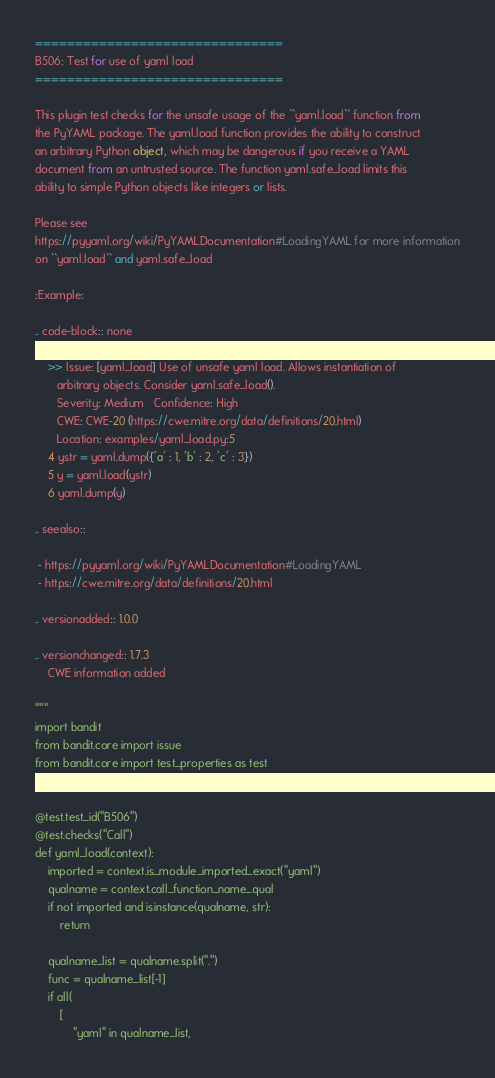<code> <loc_0><loc_0><loc_500><loc_500><_Python_>===============================
B506: Test for use of yaml load
===============================

This plugin test checks for the unsafe usage of the ``yaml.load`` function from
the PyYAML package. The yaml.load function provides the ability to construct
an arbitrary Python object, which may be dangerous if you receive a YAML
document from an untrusted source. The function yaml.safe_load limits this
ability to simple Python objects like integers or lists.

Please see
https://pyyaml.org/wiki/PyYAMLDocumentation#LoadingYAML for more information
on ``yaml.load`` and yaml.safe_load

:Example:

.. code-block:: none

    >> Issue: [yaml_load] Use of unsafe yaml load. Allows instantiation of
       arbitrary objects. Consider yaml.safe_load().
       Severity: Medium   Confidence: High
       CWE: CWE-20 (https://cwe.mitre.org/data/definitions/20.html)
       Location: examples/yaml_load.py:5
    4 ystr = yaml.dump({'a' : 1, 'b' : 2, 'c' : 3})
    5 y = yaml.load(ystr)
    6 yaml.dump(y)

.. seealso::

 - https://pyyaml.org/wiki/PyYAMLDocumentation#LoadingYAML
 - https://cwe.mitre.org/data/definitions/20.html

.. versionadded:: 1.0.0

.. versionchanged:: 1.7.3
    CWE information added

"""
import bandit
from bandit.core import issue
from bandit.core import test_properties as test


@test.test_id("B506")
@test.checks("Call")
def yaml_load(context):
    imported = context.is_module_imported_exact("yaml")
    qualname = context.call_function_name_qual
    if not imported and isinstance(qualname, str):
        return

    qualname_list = qualname.split(".")
    func = qualname_list[-1]
    if all(
        [
            "yaml" in qualname_list,</code> 